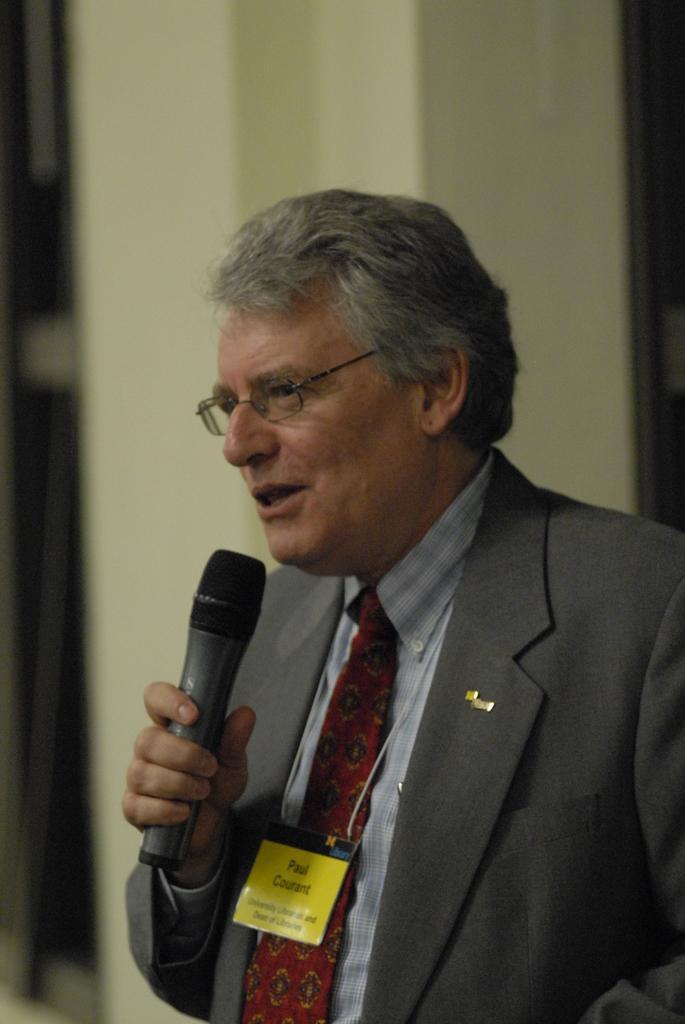Please provide a concise description of this image. in the picture person is holding a microphone and singing. 